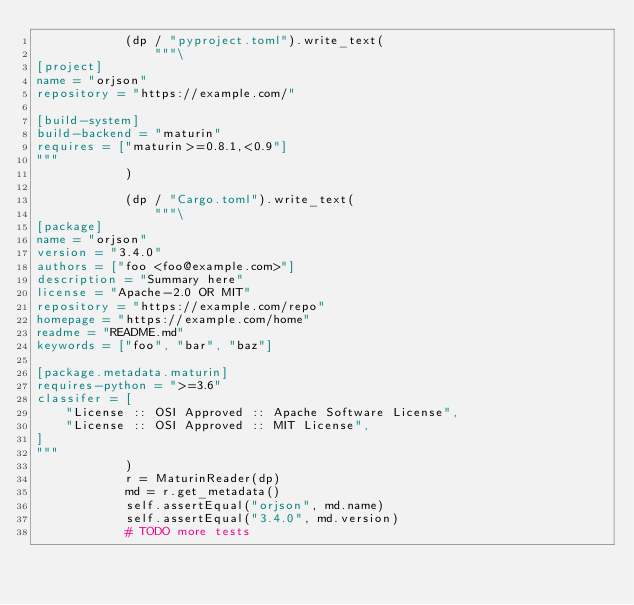<code> <loc_0><loc_0><loc_500><loc_500><_Python_>            (dp / "pyproject.toml").write_text(
                """\
[project]
name = "orjson"
repository = "https://example.com/"

[build-system]
build-backend = "maturin"
requires = ["maturin>=0.8.1,<0.9"]
"""
            )

            (dp / "Cargo.toml").write_text(
                """\
[package]
name = "orjson"
version = "3.4.0"
authors = ["foo <foo@example.com>"]
description = "Summary here"
license = "Apache-2.0 OR MIT"
repository = "https://example.com/repo"
homepage = "https://example.com/home"
readme = "README.md"
keywords = ["foo", "bar", "baz"]

[package.metadata.maturin]
requires-python = ">=3.6"
classifer = [
    "License :: OSI Approved :: Apache Software License",
    "License :: OSI Approved :: MIT License",
]
"""
            )
            r = MaturinReader(dp)
            md = r.get_metadata()
            self.assertEqual("orjson", md.name)
            self.assertEqual("3.4.0", md.version)
            # TODO more tests
</code> 